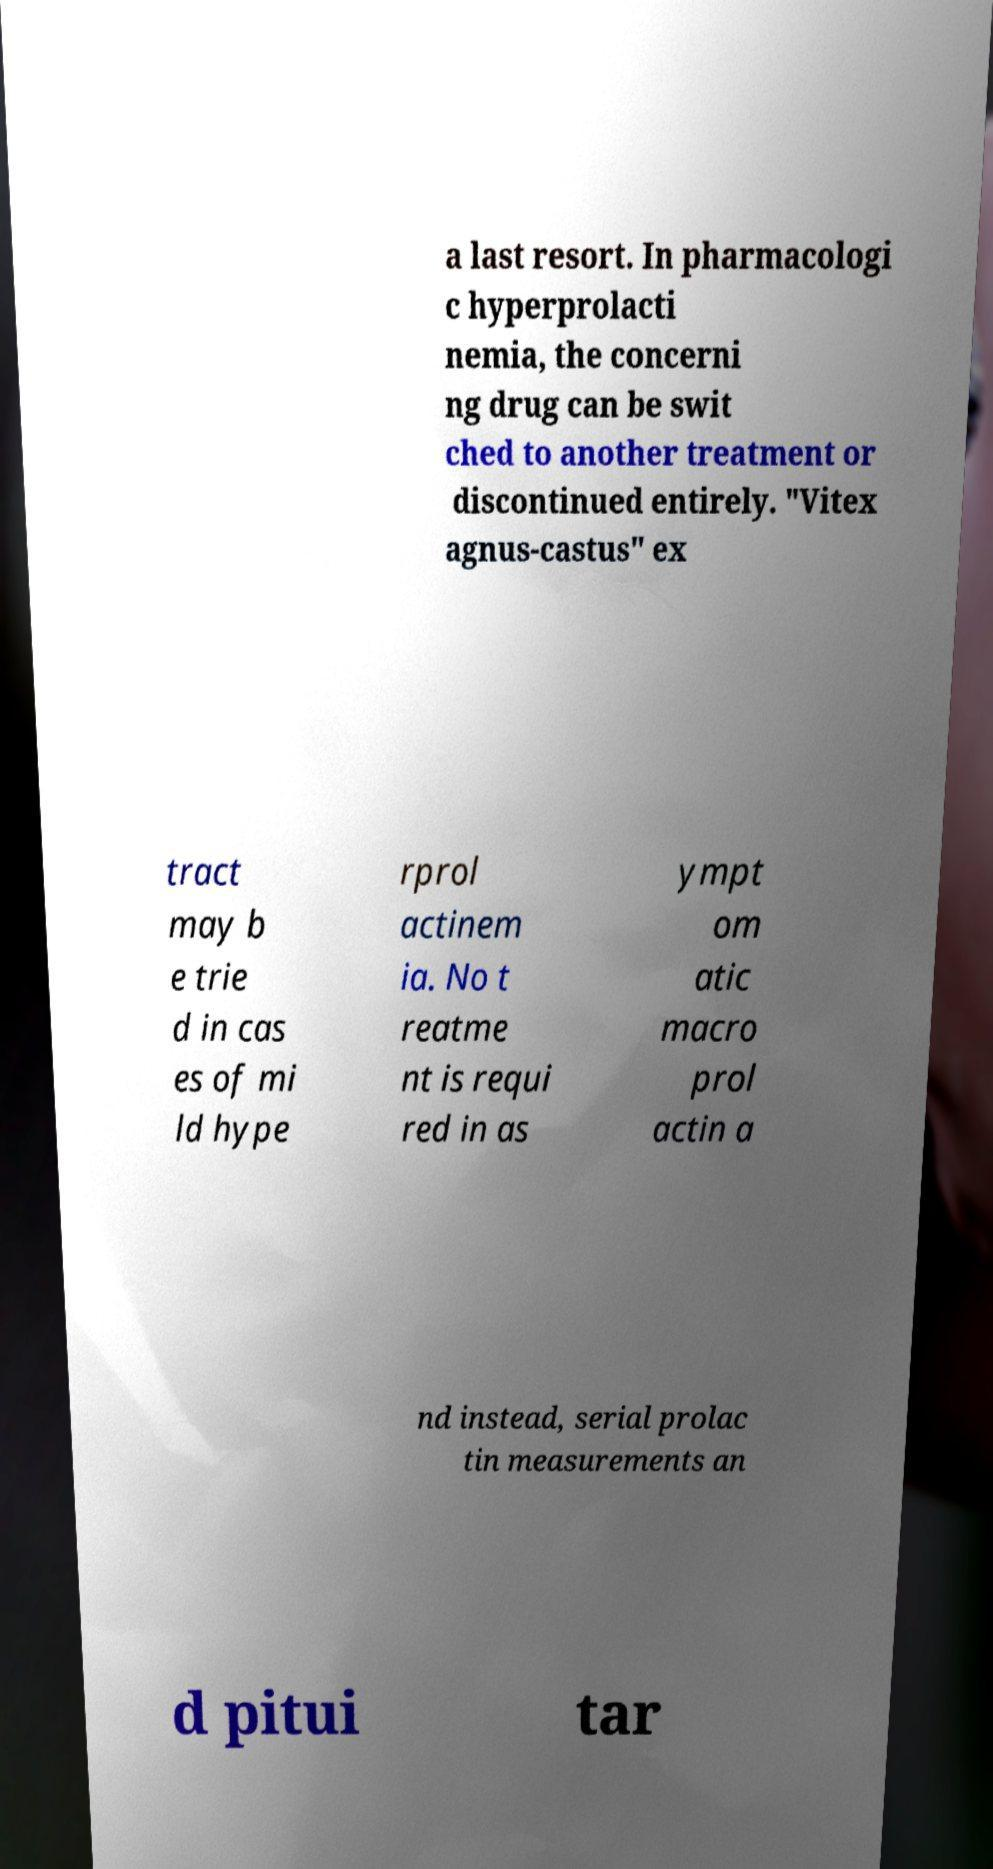What messages or text are displayed in this image? I need them in a readable, typed format. a last resort. In pharmacologi c hyperprolacti nemia, the concerni ng drug can be swit ched to another treatment or discontinued entirely. "Vitex agnus-castus" ex tract may b e trie d in cas es of mi ld hype rprol actinem ia. No t reatme nt is requi red in as ympt om atic macro prol actin a nd instead, serial prolac tin measurements an d pitui tar 